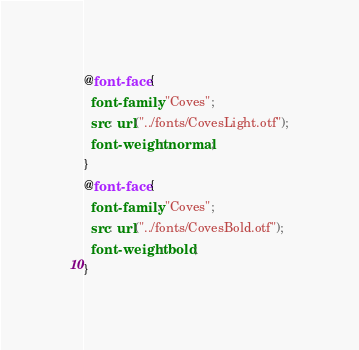Convert code to text. <code><loc_0><loc_0><loc_500><loc_500><_CSS_>@font-face {
  font-family: "Coves";
  src: url("../fonts/CovesLight.otf");
  font-weight: normal;
}
@font-face {
  font-family: "Coves";
  src: url("../fonts/CovesBold.otf");
  font-weight: bold;
}
</code> 